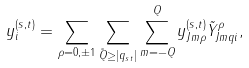<formula> <loc_0><loc_0><loc_500><loc_500>y _ { i } ^ { ( s , t ) } = \sum _ { \rho = 0 , \pm 1 } \sum _ { \tilde { Q } \geq | q _ { s t } | } \sum _ { m = - Q } ^ { Q } y _ { J m \rho } ^ { ( s , t ) } \tilde { Y } _ { J m q i } ^ { \rho } ,</formula> 